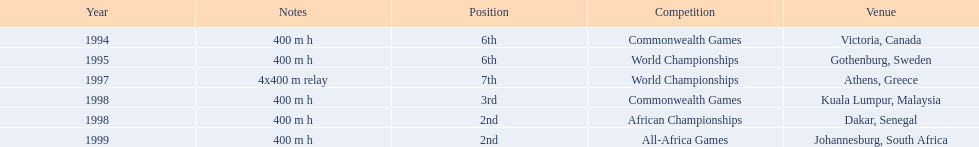What country was the 1997 championships held in? Athens, Greece. What long was the relay? 4x400 m relay. 